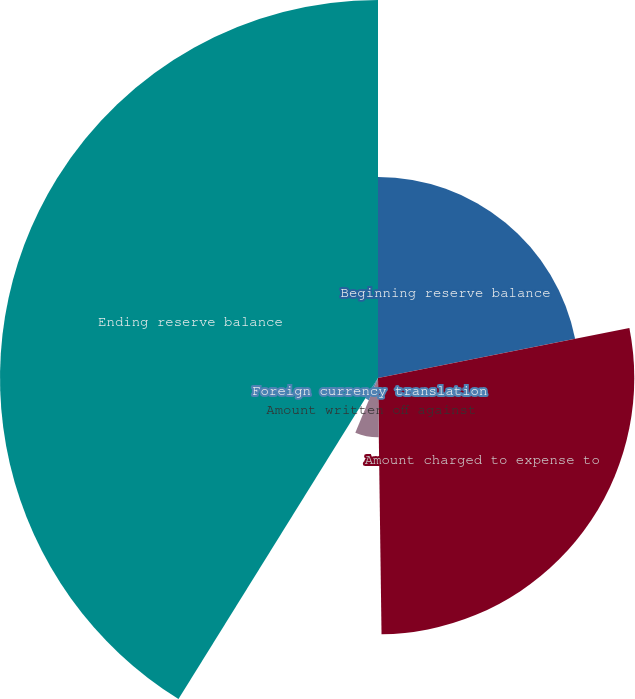Convert chart. <chart><loc_0><loc_0><loc_500><loc_500><pie_chart><fcel>Beginning reserve balance<fcel>Amount charged to expense to<fcel>Amount written off against<fcel>Foreign currency translation<fcel>Ending reserve balance<nl><fcel>21.88%<fcel>27.9%<fcel>6.46%<fcel>2.61%<fcel>41.15%<nl></chart> 